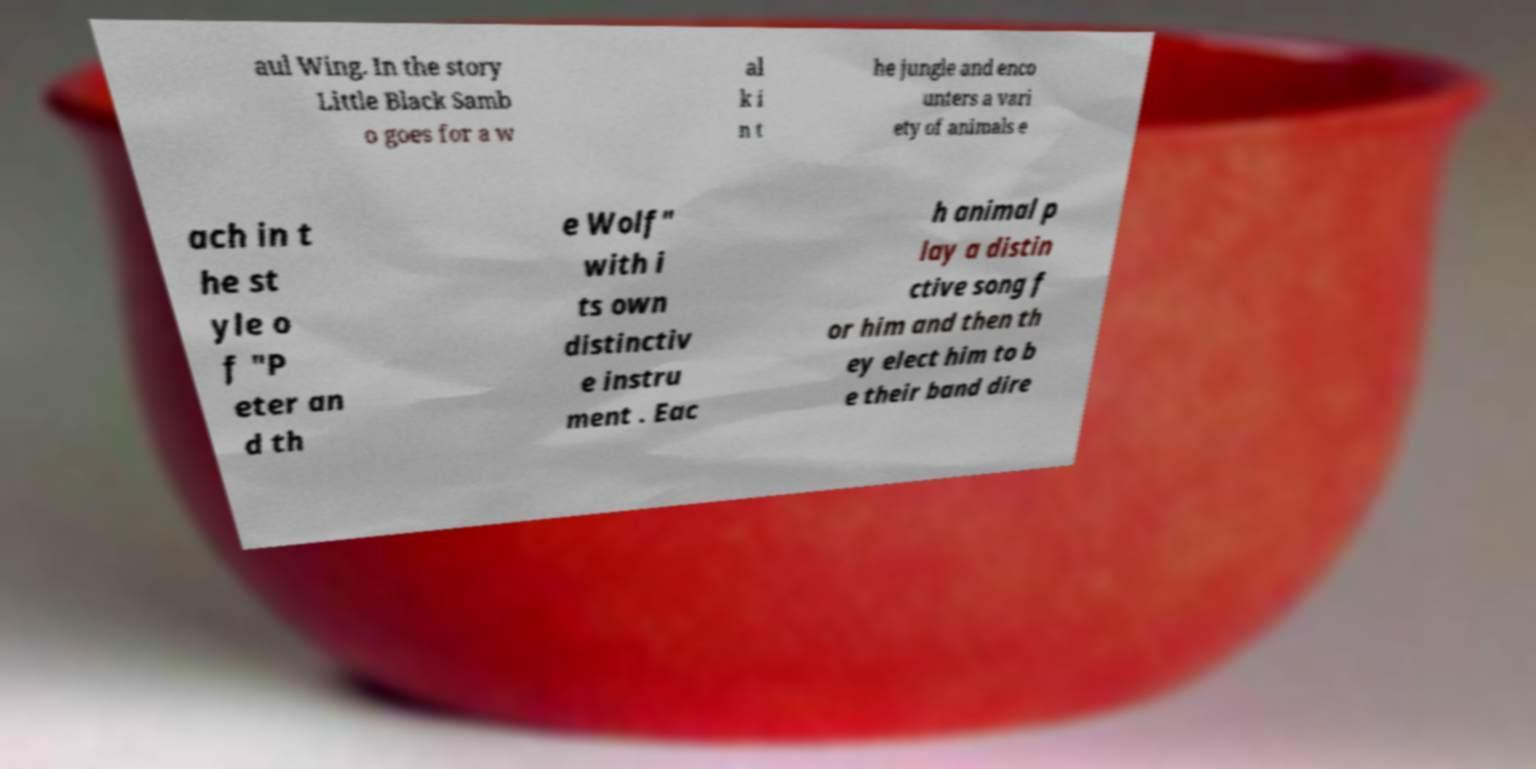Please identify and transcribe the text found in this image. aul Wing. In the story Little Black Samb o goes for a w al k i n t he jungle and enco unters a vari ety of animals e ach in t he st yle o f "P eter an d th e Wolf" with i ts own distinctiv e instru ment . Eac h animal p lay a distin ctive song f or him and then th ey elect him to b e their band dire 